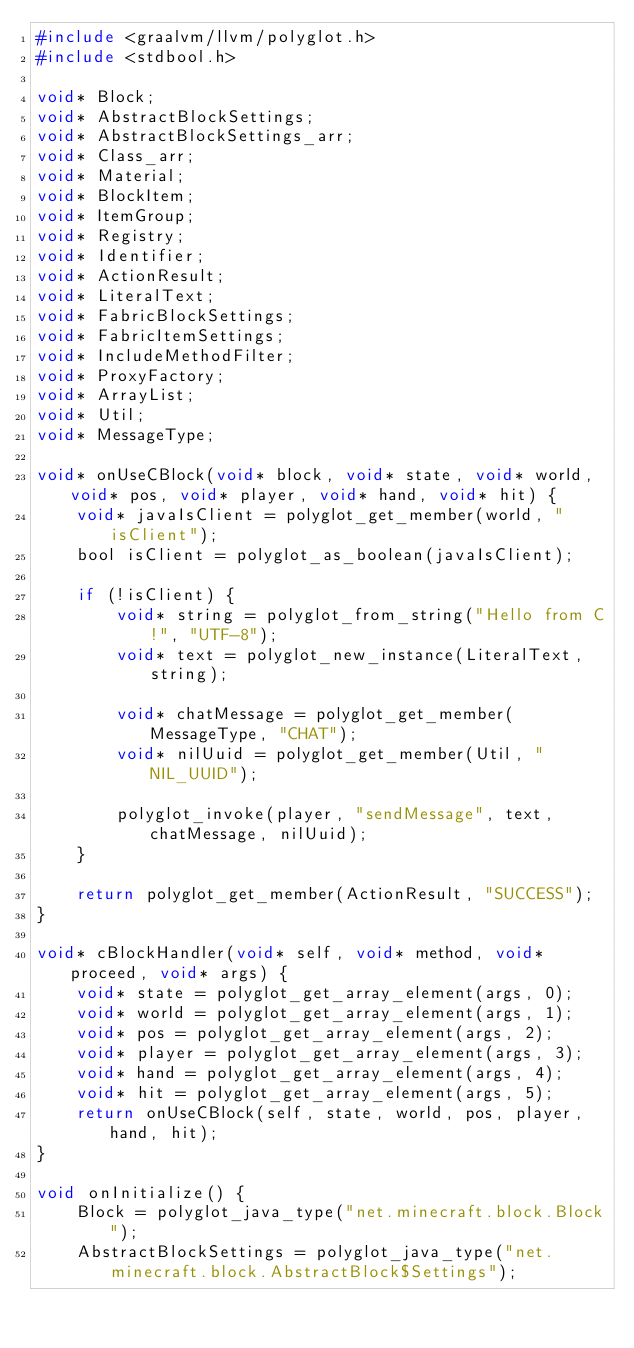Convert code to text. <code><loc_0><loc_0><loc_500><loc_500><_C_>#include <graalvm/llvm/polyglot.h>
#include <stdbool.h>

void* Block;
void* AbstractBlockSettings;
void* AbstractBlockSettings_arr;
void* Class_arr;
void* Material;
void* BlockItem;
void* ItemGroup;
void* Registry;
void* Identifier;
void* ActionResult;
void* LiteralText;
void* FabricBlockSettings;
void* FabricItemSettings;
void* IncludeMethodFilter;
void* ProxyFactory;
void* ArrayList;
void* Util;
void* MessageType;

void* onUseCBlock(void* block, void* state, void* world, void* pos, void* player, void* hand, void* hit) {
    void* javaIsClient = polyglot_get_member(world, "isClient");
    bool isClient = polyglot_as_boolean(javaIsClient);

    if (!isClient) {
        void* string = polyglot_from_string("Hello from C!", "UTF-8");
        void* text = polyglot_new_instance(LiteralText, string);

        void* chatMessage = polyglot_get_member(MessageType, "CHAT");
        void* nilUuid = polyglot_get_member(Util, "NIL_UUID");

        polyglot_invoke(player, "sendMessage", text, chatMessage, nilUuid);
    }

    return polyglot_get_member(ActionResult, "SUCCESS");
}

void* cBlockHandler(void* self, void* method, void* proceed, void* args) {
    void* state = polyglot_get_array_element(args, 0);
    void* world = polyglot_get_array_element(args, 1);
    void* pos = polyglot_get_array_element(args, 2);
    void* player = polyglot_get_array_element(args, 3);
    void* hand = polyglot_get_array_element(args, 4);
    void* hit = polyglot_get_array_element(args, 5);
    return onUseCBlock(self, state, world, pos, player, hand, hit);
}

void onInitialize() {
    Block = polyglot_java_type("net.minecraft.block.Block");
    AbstractBlockSettings = polyglot_java_type("net.minecraft.block.AbstractBlock$Settings");</code> 